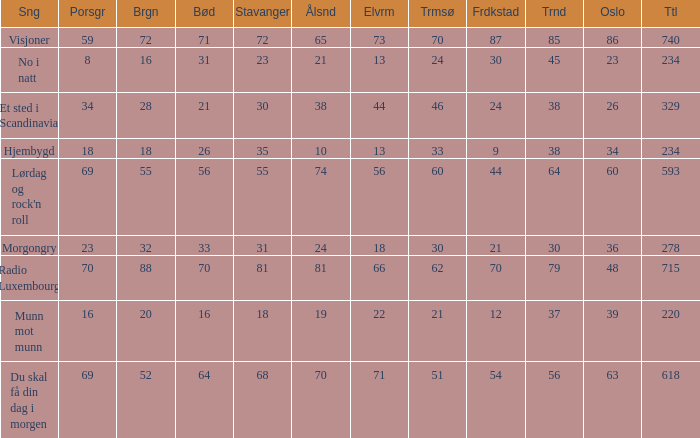What is the lowest total? 220.0. 